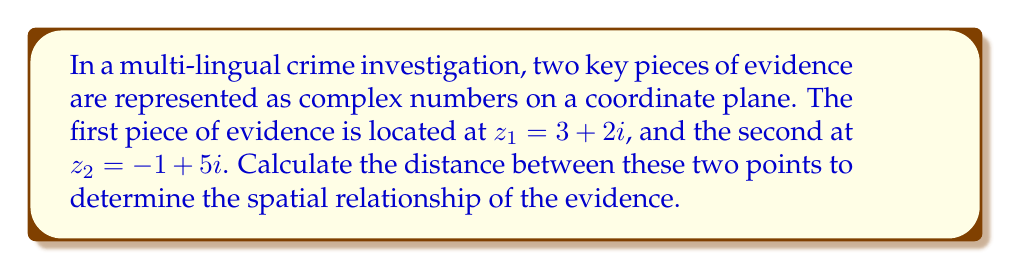Provide a solution to this math problem. To calculate the distance between two points on the complex plane, we use the distance formula:

$$d = \sqrt{(x_2 - x_1)^2 + (y_2 - y_1)^2}$$

Where $(x_1, y_1)$ represents the coordinates of the first point and $(x_2, y_2)$ represents the coordinates of the second point.

For complex numbers, we can rewrite this as:

$$d = |z_2 - z_1|$$

Where $|z|$ denotes the absolute value or modulus of a complex number.

Step 1: Calculate $z_2 - z_1$
$z_2 - z_1 = (-1 + 5i) - (3 + 2i) = -4 + 3i$

Step 2: Calculate $|z_2 - z_1|$
For a complex number $a + bi$, the absolute value is given by $\sqrt{a^2 + b^2}$

$$|-4 + 3i| = \sqrt{(-4)^2 + 3^2} = \sqrt{16 + 9} = \sqrt{25} = 5$$

Therefore, the distance between the two points is 5 units.
Answer: $5$ units 